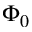<formula> <loc_0><loc_0><loc_500><loc_500>\Phi _ { 0 }</formula> 